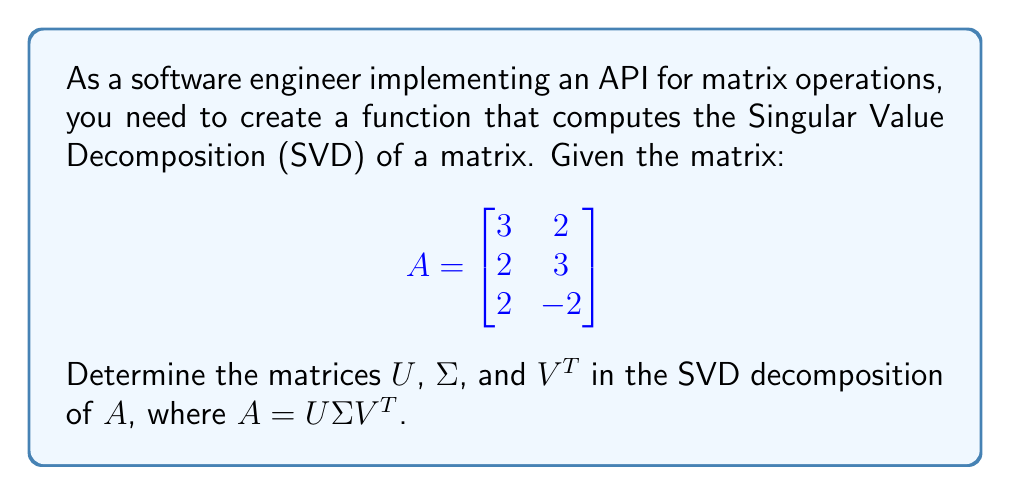What is the answer to this math problem? To find the SVD of matrix A, we'll follow these steps:

1. Calculate A^T * A and A * A^T:
   
   $$A^T * A = \begin{bmatrix}
   3 & 2 & 2 \\
   2 & 3 & -2
   \end{bmatrix} \begin{bmatrix}
   3 & 2 \\
   2 & 3 \\
   2 & -2
   \end{bmatrix} = \begin{bmatrix}
   17 & 8 \\
   8 & 17
   \end{bmatrix}$$

   $$A * A^T = \begin{bmatrix}
   3 & 2 \\
   2 & 3 \\
   2 & -2
   \end{bmatrix} \begin{bmatrix}
   3 & 2 & 2 \\
   2 & 3 & -2
   \end{bmatrix} = \begin{bmatrix}
   13 & 12 & 2 \\
   12 & 13 & -2 \\
   2 & -2 & 8
   \end{bmatrix}$$

2. Find eigenvalues and eigenvectors of A^T * A:
   Characteristic equation: $det(A^T A - \lambda I) = (17-\lambda)^2 - 64 = 0$
   Solving this, we get: $\lambda_1 = 25, \lambda_2 = 9$

   For $\lambda_1 = 25$: $(A^T A - 25I)v = 0$ gives $v_1 = [1, 1]^T$
   For $\lambda_2 = 9$: $(A^T A - 9I)v = 0$ gives $v_2 = [-1, 1]^T$

   Normalizing these vectors, we get:
   $$V = \begin{bmatrix}
   \frac{1}{\sqrt{2}} & -\frac{1}{\sqrt{2}} \\
   \frac{1}{\sqrt{2}} & \frac{1}{\sqrt{2}}
   \end{bmatrix}$$

3. Calculate singular values:
   $\sigma_1 = \sqrt{25} = 5, \sigma_2 = \sqrt{9} = 3$

   $$\Sigma = \begin{bmatrix}
   5 & 0 \\
   0 & 3 \\
   0 & 0
   \end{bmatrix}$$

4. Calculate left singular vectors (columns of U):
   $u_1 = \frac{1}{\sigma_1}Av_1, u_2 = \frac{1}{\sigma_2}Av_2$

   $$u_1 = \frac{1}{5}\begin{bmatrix}
   3 & 2 \\
   2 & 3 \\
   2 & -2
   \end{bmatrix}\begin{bmatrix}
   \frac{1}{\sqrt{2}} \\
   \frac{1}{\sqrt{2}}
   \end{bmatrix} = \frac{1}{\sqrt{2}}\begin{bmatrix}
   1 \\
   1 \\
   0
   \end{bmatrix}$$

   $$u_2 = \frac{1}{3}\begin{bmatrix}
   3 & 2 \\
   2 & 3 \\
   2 & -2
   \end{bmatrix}\begin{bmatrix}
   -\frac{1}{\sqrt{2}} \\
   \frac{1}{\sqrt{2}}
   \end{bmatrix} = \frac{1}{\sqrt{6}}\begin{bmatrix}
   -1 \\
   1 \\
   2
   \end{bmatrix}$$

   The third column of U is orthogonal to $u_1$ and $u_2$:
   $$u_3 = \frac{1}{\sqrt{3}}\begin{bmatrix}
   1 \\
   1 \\
   -1
   \end{bmatrix}$$

   $$U = \begin{bmatrix}
   \frac{1}{\sqrt{2}} & -\frac{1}{\sqrt{6}} & \frac{1}{\sqrt{3}} \\
   \frac{1}{\sqrt{2}} & \frac{1}{\sqrt{6}} & \frac{1}{\sqrt{3}} \\
   0 & \frac{2}{\sqrt{6}} & -\frac{1}{\sqrt{3}}
   \end{bmatrix}$$
Answer: U = $\begin{bmatrix}
\frac{1}{\sqrt{2}} & -\frac{1}{\sqrt{6}} & \frac{1}{\sqrt{3}} \\
\frac{1}{\sqrt{2}} & \frac{1}{\sqrt{6}} & \frac{1}{\sqrt{3}} \\
0 & \frac{2}{\sqrt{6}} & -\frac{1}{\sqrt{3}}
\end{bmatrix}$, Σ = $\begin{bmatrix}
5 & 0 \\
0 & 3 \\
0 & 0
\end{bmatrix}$, V^T = $\begin{bmatrix}
\frac{1}{\sqrt{2}} & \frac{1}{\sqrt{2}} \\
-\frac{1}{\sqrt{2}} & \frac{1}{\sqrt{2}}
\end{bmatrix}$ 